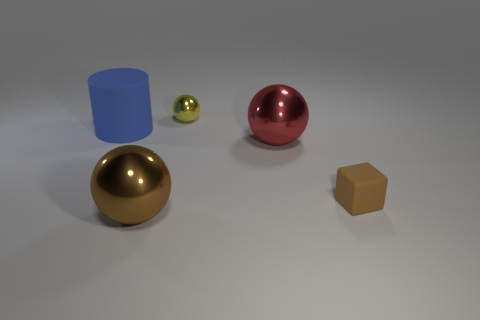What materials are the objects in the image made of? The objects in the image appear to have different materials. The large sphere seems to be made of a shiny, reflective metal, possibly bronze, while the blue cylinder looks like it has a matte plastic finish. The tiny brown block appears to be wooden due to its matte texture, and the red sphere has a glossy, metallic finish, suggesting it could also be a painted metal. Lastly, the small green sphere has a similar shiny finish to the red sphere, which might indicate a polished metal or a reflective plastic material. 